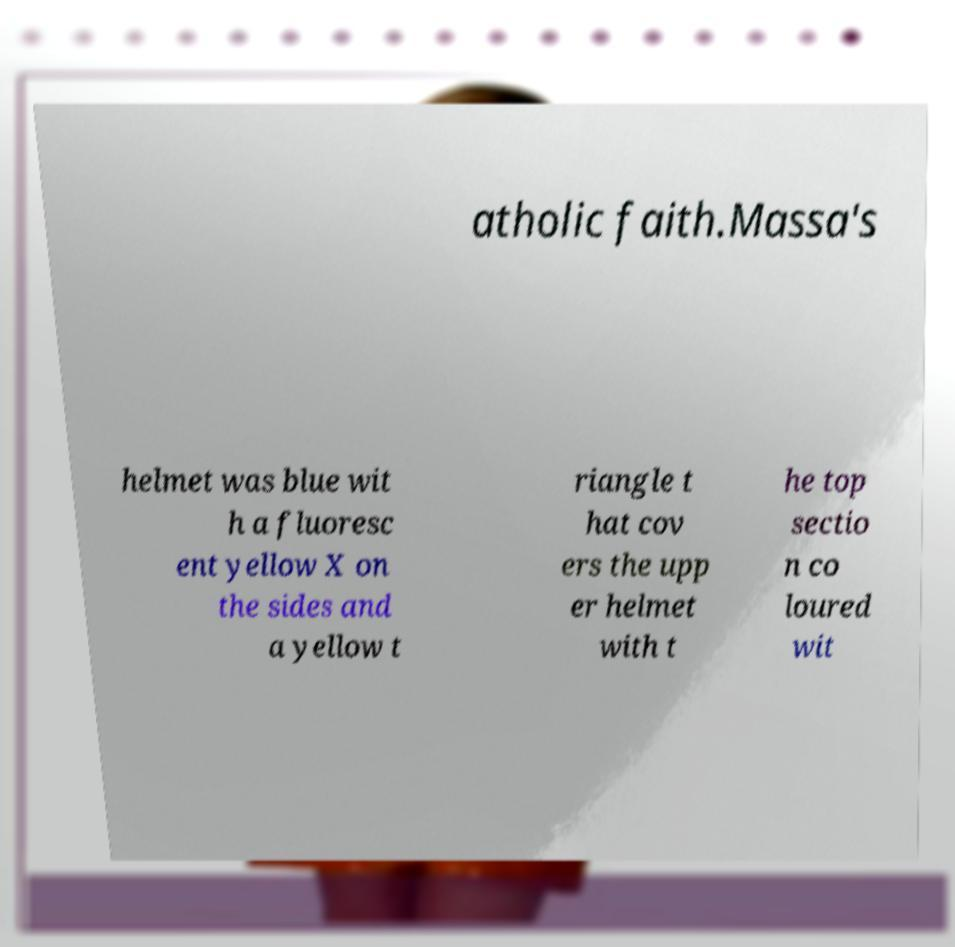Can you read and provide the text displayed in the image?This photo seems to have some interesting text. Can you extract and type it out for me? atholic faith.Massa's helmet was blue wit h a fluoresc ent yellow X on the sides and a yellow t riangle t hat cov ers the upp er helmet with t he top sectio n co loured wit 